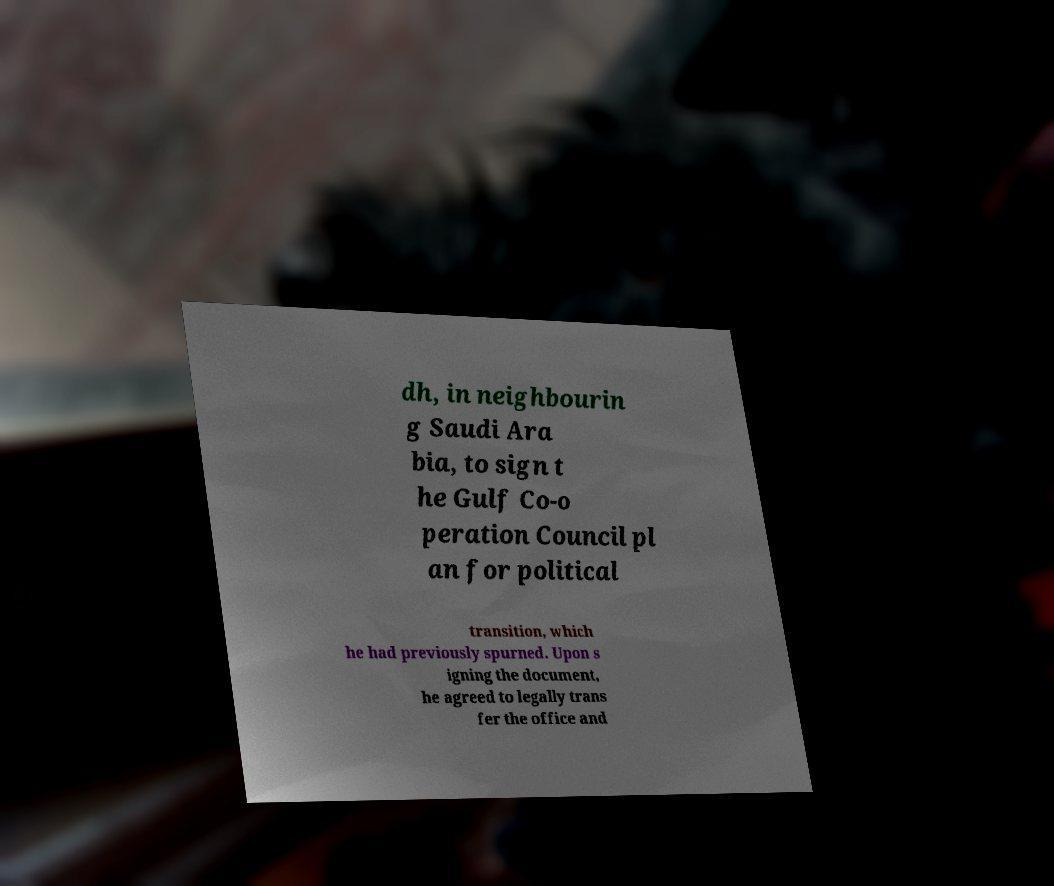Please read and relay the text visible in this image. What does it say? dh, in neighbourin g Saudi Ara bia, to sign t he Gulf Co-o peration Council pl an for political transition, which he had previously spurned. Upon s igning the document, he agreed to legally trans fer the office and 